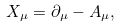Convert formula to latex. <formula><loc_0><loc_0><loc_500><loc_500>X _ { \mu } = \partial _ { \mu } - A _ { \mu } ,</formula> 